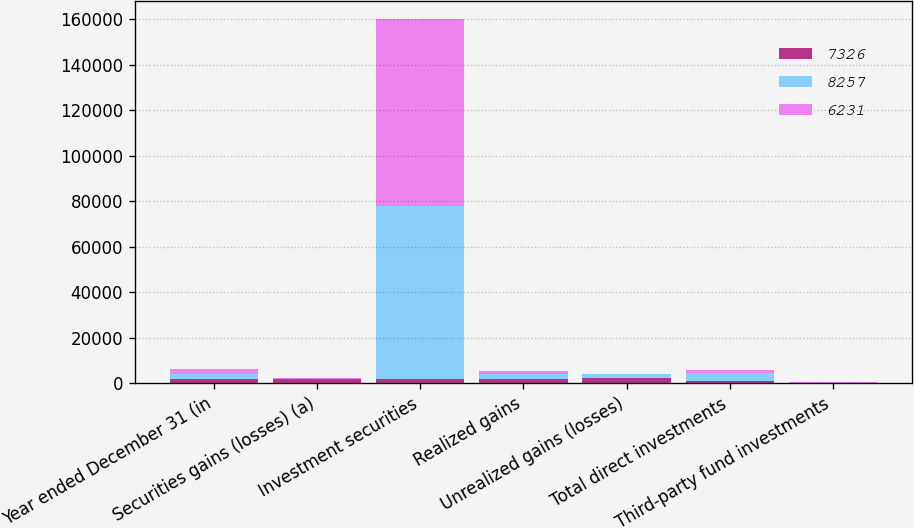Convert chart to OTSL. <chart><loc_0><loc_0><loc_500><loc_500><stacked_bar_chart><ecel><fcel>Year ended December 31 (in<fcel>Securities gains (losses) (a)<fcel>Investment securities<fcel>Realized gains<fcel>Unrealized gains (losses)<fcel>Total direct investments<fcel>Third-party fund investments<nl><fcel>7326<fcel>2008<fcel>1652<fcel>1717<fcel>1717<fcel>2480<fcel>763<fcel>131<nl><fcel>8257<fcel>2007<fcel>37<fcel>76200<fcel>2312<fcel>1607<fcel>3919<fcel>165<nl><fcel>6231<fcel>2006<fcel>619<fcel>82091<fcel>1223<fcel>1<fcel>1222<fcel>77<nl></chart> 